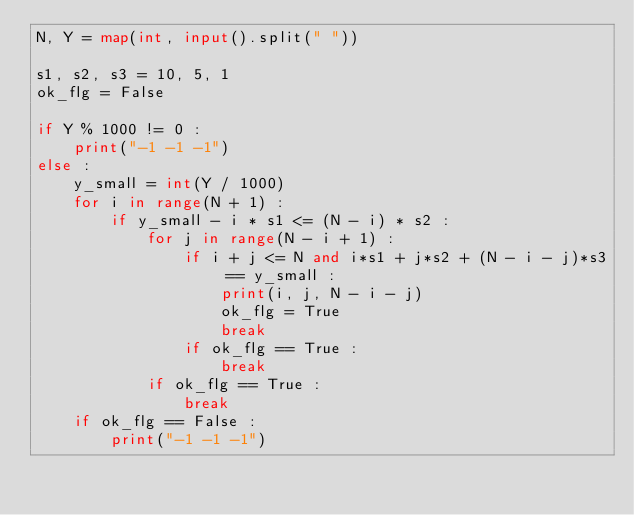<code> <loc_0><loc_0><loc_500><loc_500><_Python_>N, Y = map(int, input().split(" "))

s1, s2, s3 = 10, 5, 1
ok_flg = False

if Y % 1000 != 0 :
    print("-1 -1 -1")    
else :
    y_small = int(Y / 1000)
    for i in range(N + 1) :
        if y_small - i * s1 <= (N - i) * s2 :
            for j in range(N - i + 1) :
                if i + j <= N and i*s1 + j*s2 + (N - i - j)*s3 == y_small :
                    print(i, j, N - i - j)
                    ok_flg = True
                    break
                if ok_flg == True :
                    break
            if ok_flg == True :
                break
    if ok_flg == False :
        print("-1 -1 -1")</code> 